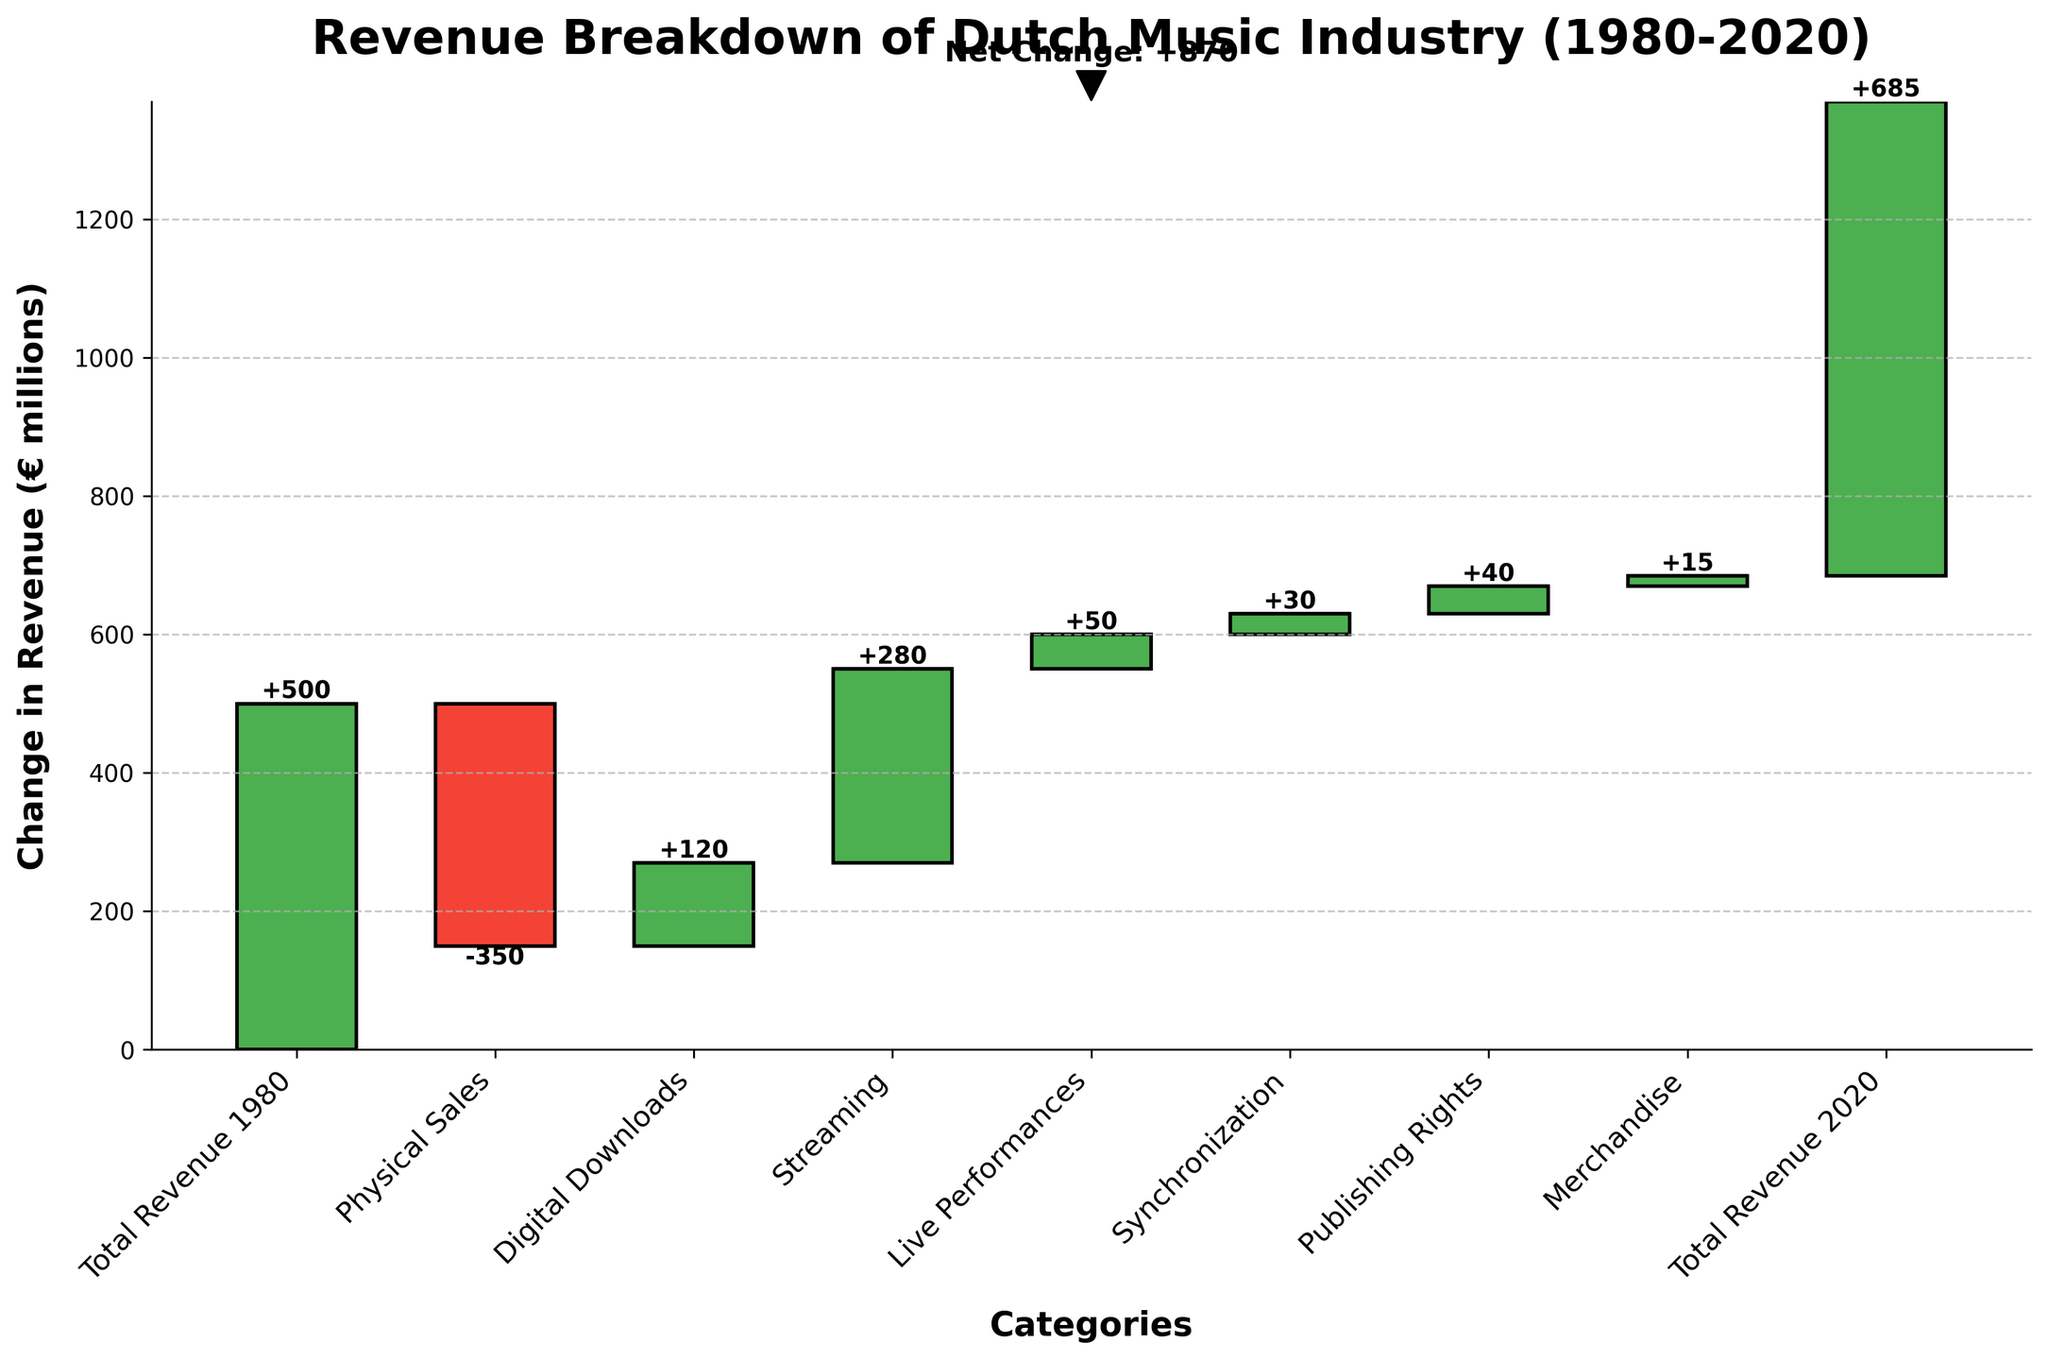How much was the total revenue for the Dutch music industry in 1980? The figure lists "Total Revenue 1980" as one of the categories with a revenue value
Answer: 500 million euros Which income stream had the largest positive change in revenue between 1980 and 2020? The largest positive change is indicated by the tallest green bar in the figure
Answer: Streaming How much did physical sales decrease from 1980 to 2020? The figure shows a negative change under the category "Physical Sales"
Answer: 350 million euros What revenue category contributed the least to the Dutch music industry’s revenue change between 1980 and 2020? The category with the smallest bar, either positive or negative, indicates the smallest contribution
Answer: Merchandise What is the net change in revenue from 1980 to 2020? The figure includes an annotation for net change, or it can be calculated by subtracting the initial total revenue from the final total revenue
Answer: 185 million euros Which income streams contributed positively to the revenue from 1980 to 2020? The positive contributions are indicated by green bars in the figure
Answer: Digital Downloads, Streaming, Live Performances, Synchronization, Publishing Rights, Merchandise What is the cumulative revenue after accounting for digital downloads and streaming? Sum the values of digital downloads and streaming and add it to the cumulative revenue before these categories
Answer: 500 - 350 + 120 + 280 = 550 million euros How does the revenue change of live performances compare to the change of synchronization? Compare the heights of the respective bars for live performances and synchronization
Answer: Live performances increased less than synchronization What overall trend does the figure suggest about the Dutch music industry's revenue sources from 1980 to 2020? By observing the mix of positive and negative changes in revenue sources
Answer: The industry shifted from physical sales to digital and live performance revenues 